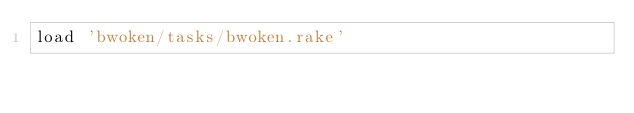Convert code to text. <code><loc_0><loc_0><loc_500><loc_500><_Ruby_>load 'bwoken/tasks/bwoken.rake'
</code> 